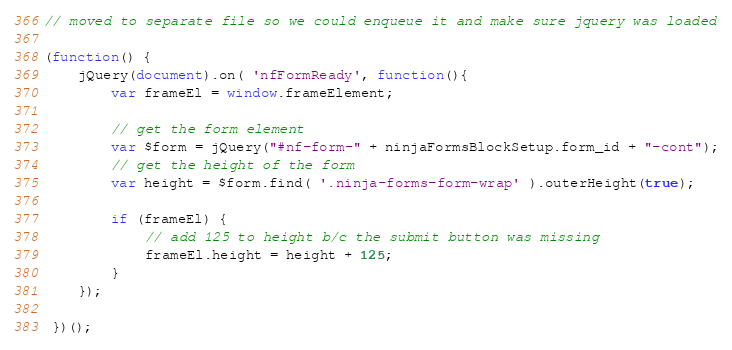<code> <loc_0><loc_0><loc_500><loc_500><_JavaScript_>// moved to separate file so we could enqueue it and make sure jquery was loaded

(function() {
    jQuery(document).on( 'nfFormReady', function(){
        var frameEl = window.frameElement;

        // get the form element
        var $form = jQuery("#nf-form-" + ninjaFormsBlockSetup.form_id + "-cont");
        // get the height of the form
        var height = $form.find( '.ninja-forms-form-wrap' ).outerHeight(true);

        if (frameEl) {
            // add 125 to height b/c the submit button was missing
            frameEl.height = height + 125;
        }
    });
 
 })();</code> 